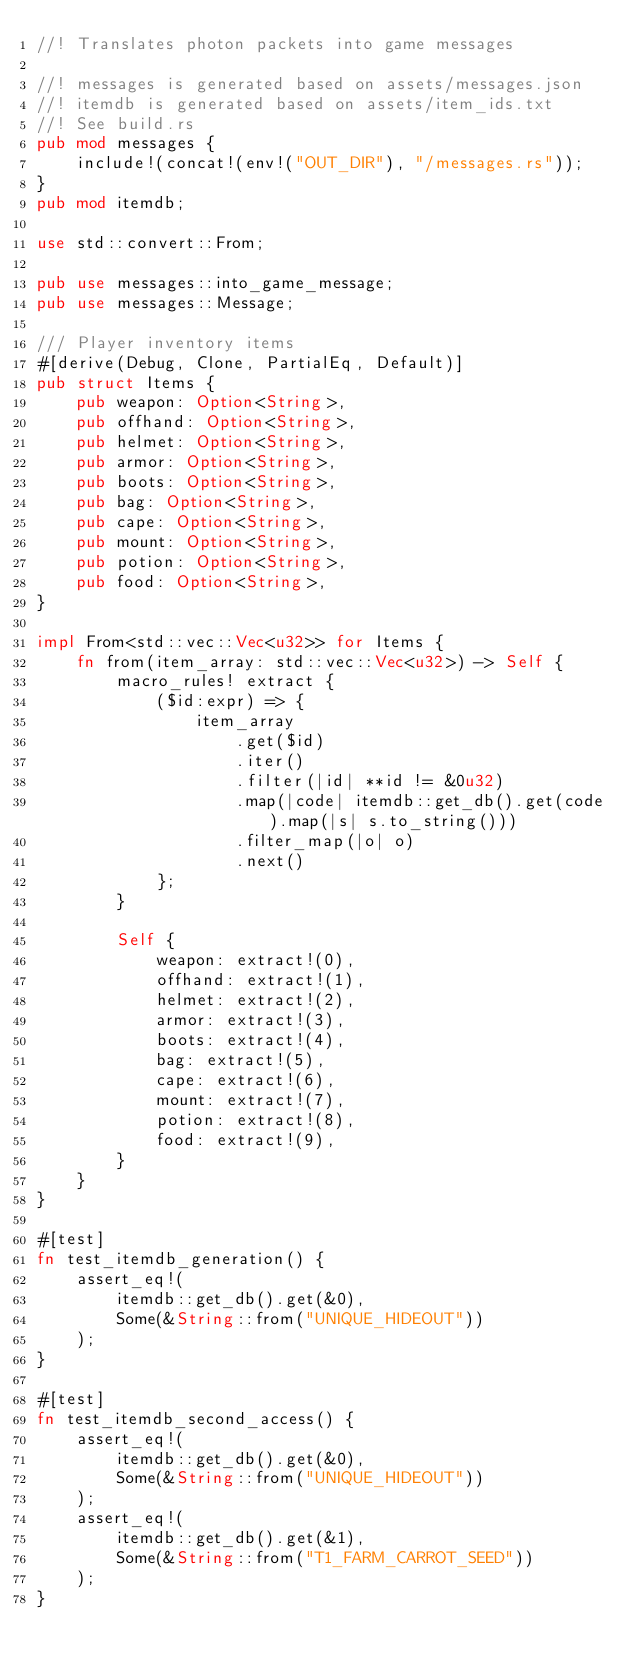<code> <loc_0><loc_0><loc_500><loc_500><_Rust_>//! Translates photon packets into game messages

//! messages is generated based on assets/messages.json
//! itemdb is generated based on assets/item_ids.txt
//! See build.rs
pub mod messages {
    include!(concat!(env!("OUT_DIR"), "/messages.rs"));
}
pub mod itemdb;

use std::convert::From;

pub use messages::into_game_message;
pub use messages::Message;

/// Player inventory items
#[derive(Debug, Clone, PartialEq, Default)]
pub struct Items {
    pub weapon: Option<String>,
    pub offhand: Option<String>,
    pub helmet: Option<String>,
    pub armor: Option<String>,
    pub boots: Option<String>,
    pub bag: Option<String>,
    pub cape: Option<String>,
    pub mount: Option<String>,
    pub potion: Option<String>,
    pub food: Option<String>,
}

impl From<std::vec::Vec<u32>> for Items {
    fn from(item_array: std::vec::Vec<u32>) -> Self {
        macro_rules! extract {
            ($id:expr) => {
                item_array
                    .get($id)
                    .iter()
                    .filter(|id| **id != &0u32)
                    .map(|code| itemdb::get_db().get(code).map(|s| s.to_string()))
                    .filter_map(|o| o)
                    .next()
            };
        }

        Self {
            weapon: extract!(0),
            offhand: extract!(1),
            helmet: extract!(2),
            armor: extract!(3),
            boots: extract!(4),
            bag: extract!(5),
            cape: extract!(6),
            mount: extract!(7),
            potion: extract!(8),
            food: extract!(9),
        }
    }
}

#[test]
fn test_itemdb_generation() {
    assert_eq!(
        itemdb::get_db().get(&0),
        Some(&String::from("UNIQUE_HIDEOUT"))
    );
}

#[test]
fn test_itemdb_second_access() {
    assert_eq!(
        itemdb::get_db().get(&0),
        Some(&String::from("UNIQUE_HIDEOUT"))
    );
    assert_eq!(
        itemdb::get_db().get(&1),
        Some(&String::from("T1_FARM_CARROT_SEED"))
    );
}
</code> 